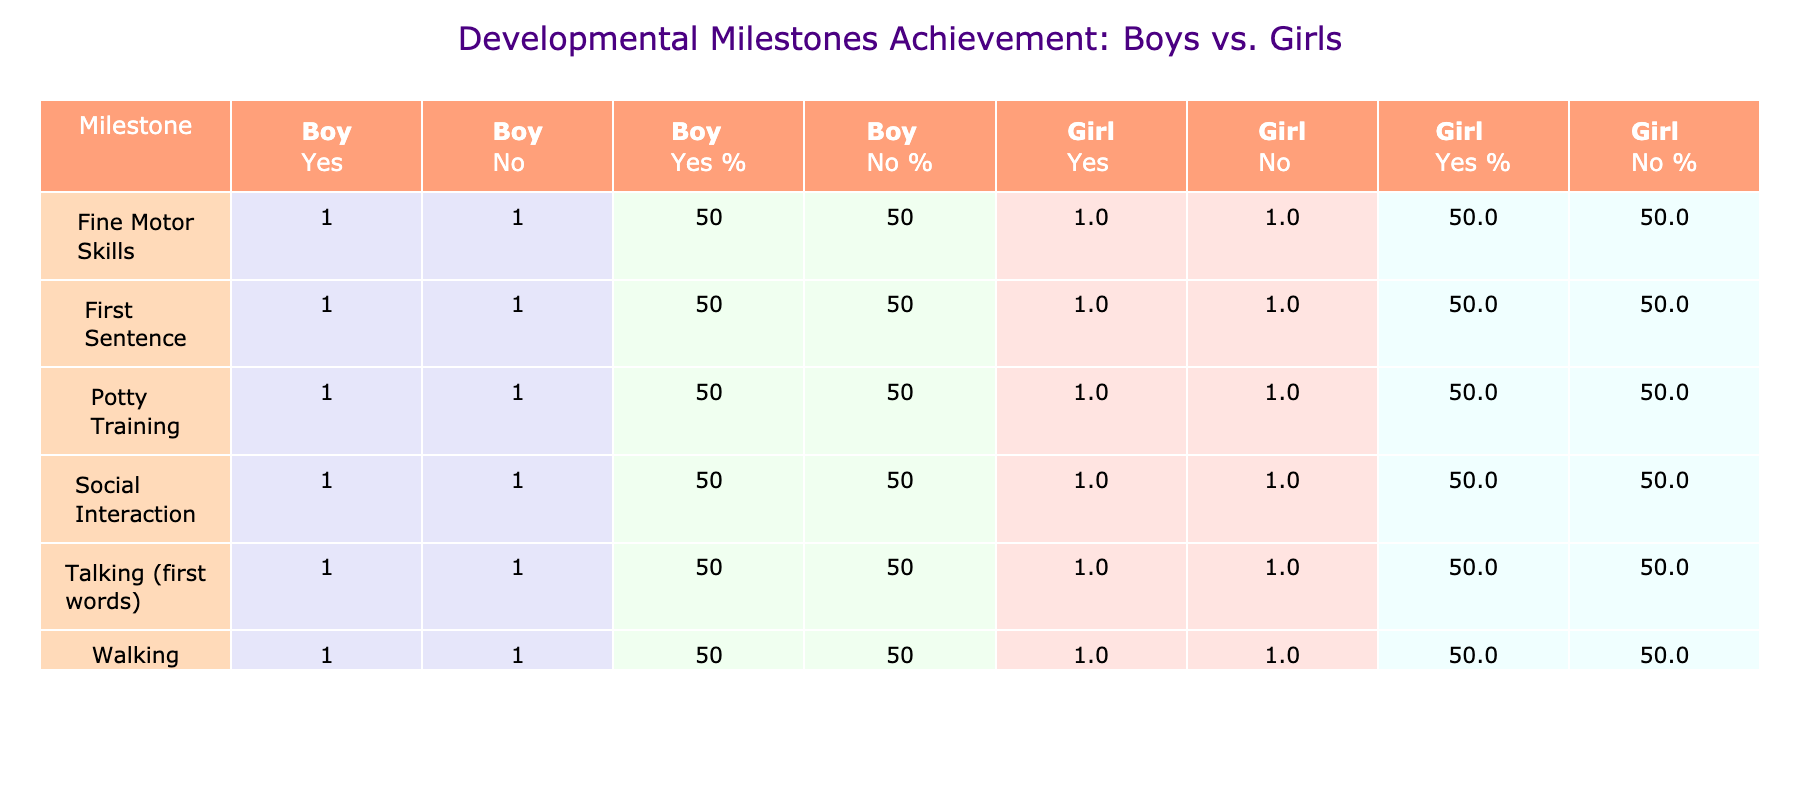What percentage of boys achieved potty training? From the table, for potty training, 2 boys achieved it (Yes), and there are a total of 4 boys (2 Yes and 2 No). To find the percentage, we calculate (2 / 4) * 100 = 50%.
Answer: 50% What is the percentage of girls who did not achieve talking? Looking at the talking milestone, 2 girls did not achieve it (No) out of 4 total girls (2 Yes and 2 No). The percentage is (2 / 4) * 100 = 50%.
Answer: 50% Did more boys or girls successfully achieve walking? For walking, 2 boys and 2 girls achieved it. Since both genders have the same count, neither achieved more than the other.
Answer: Neither What is the difference in the number of boys and girls who achieved fine motor skills? From the table, both 2 boys and 2 girls achieved fine motor skills. Thus, the difference is 2 - 2 = 0, meaning there is no difference.
Answer: 0 What is the total number of girls who achieved social interaction compared to those who did not? There are 2 girls who achieved social interaction (Yes) and 2 girls who did not (No). To compare, there are equal totals of 2 Yes and 2 No.
Answer: Equal Which developmental milestone had the highest percentage of achievement for boys? The achievements for boys show that all milestones have 50% Yes and 50% No. Thus, none stand out, showing equal achievement across all milestones.
Answer: Equal across milestones What is the overall achievement for talking among boys? For boys, there are 2 who achieved talking (Yes) and 2 who did not (No), giving an overall percentage of (2 / 4) * 100 = 50%.
Answer: 50% Did the boys or girls show earlier achievement in social interaction? Both boys and girls have the same achievement of 2 Yes and 2 No for social interaction. Therefore, neither gender shows earlier achievement.
Answer: Neither What is the total percentage of achievements for boys across all milestones? Each milestone for boys has an achievement of 50% Yes (2 Yes out of 4 total for each). Thus, the total percentage of achievements across all milestones remains 50%.
Answer: 50% 